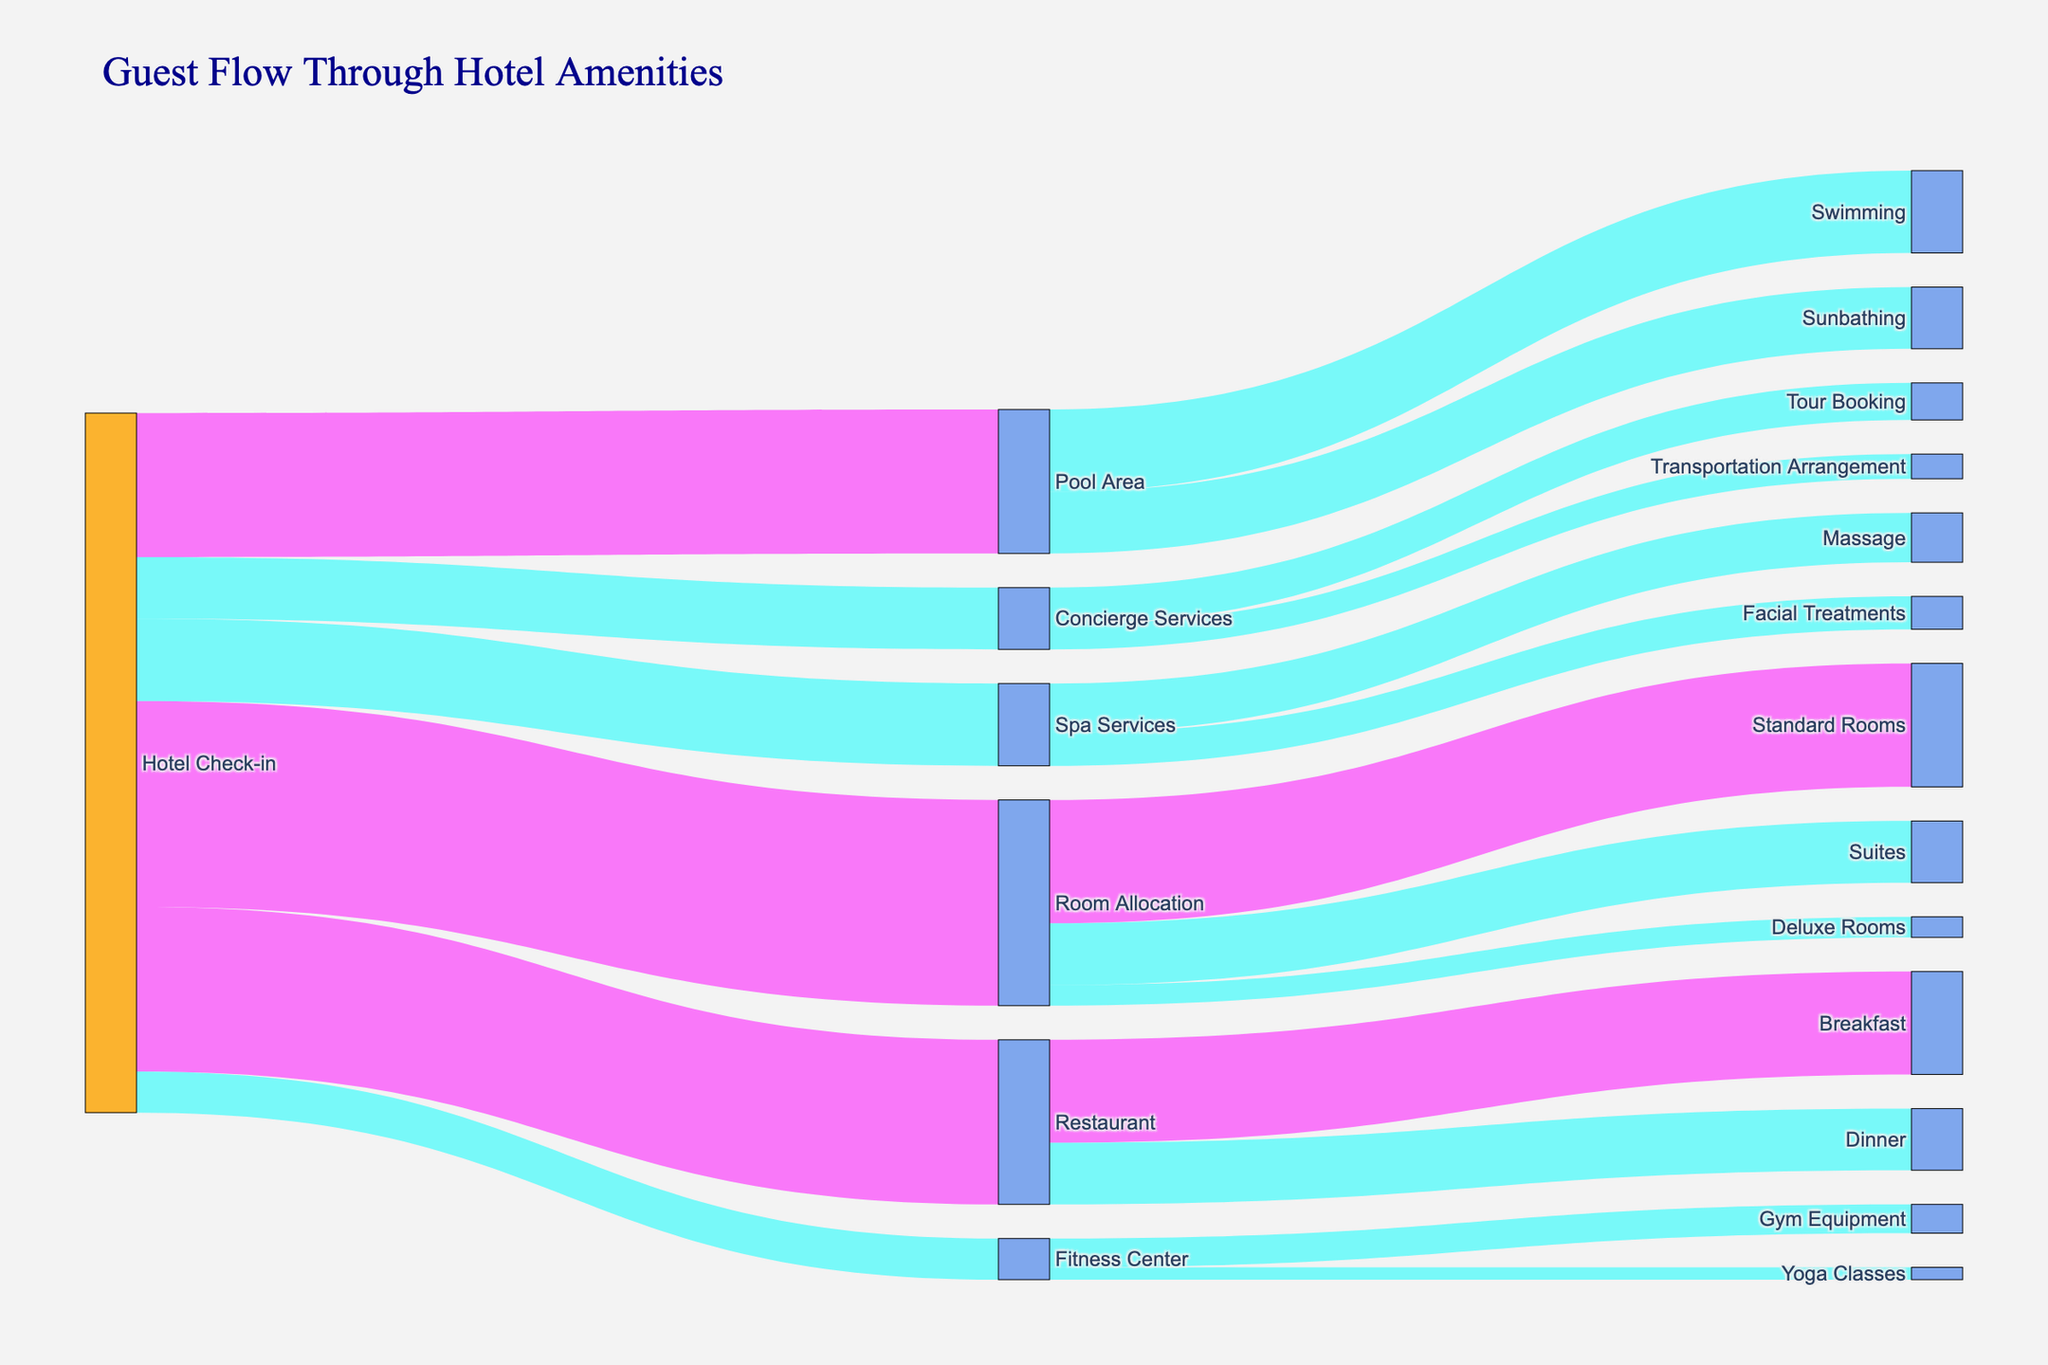What's the title of the Sankey diagram? The title is typically positioned at the top of the diagram. In this case, it is "Guest Flow Through Hotel Amenities".
Answer: Guest Flow Through Hotel Amenities What is the total number of guests that checked in? To find the total number of guests who checked in, sum the values flowing out from "Hotel Check-in": 500 (Room Allocation) + 200 (Spa Services) + 400 (Restaurant) + 350 (Pool Area) + 150 (Concierge Services) + 100 (Fitness Center) = 1700.
Answer: 1700 Which amenity had the highest number of guests, and how many? By looking at the flow values directly linked to "Hotel Check-in," the highest value is 500, which went to "Room Allocation."
Answer: Room Allocation, 500 How many guests used the Spa Services? The diagram shows a direct flow value from "Hotel Check-in" to "Spa Services" as 200.
Answer: 200 Which service under the Pool Area was more popular, Swimming or Sunbathing? Compare the flows from "Pool Area": Swimming (200) vs. Sunbathing (150). Swimming has more guests.
Answer: Swimming What percentage of guests went to the Restaurant after check-in? The number of guests who went to the Restaurant is 400 out of a total of 1700 check-ins. The percentage is (400/1700) * 100 = 23.53%.
Answer: 23.53% What is the total number of guests who booked tours through Concierge Services? The flow from "Concierge Services" to "Tour Booking" shows 90 guests.
Answer: 90 How many guests opted for Yoga Classes at the Fitness Center? The flow value from "Fitness Center" to "Yoga Classes" in the diagram is 30.
Answer: 30 Out of the guests that went to Restaurant, how many had Dinner? The diagram shows a flow of 150 guests from the Restaurant to Dinner.
Answer: 150 Compare the number of guests who went sunbathing and those who booked transportation arrangements. The diagram shows 150 guests opted for Sunbathing and 60 guests for Transportation Arrangement. Comparing these, Sunbathing had more guests.
Answer: Sunbathing had more guests 